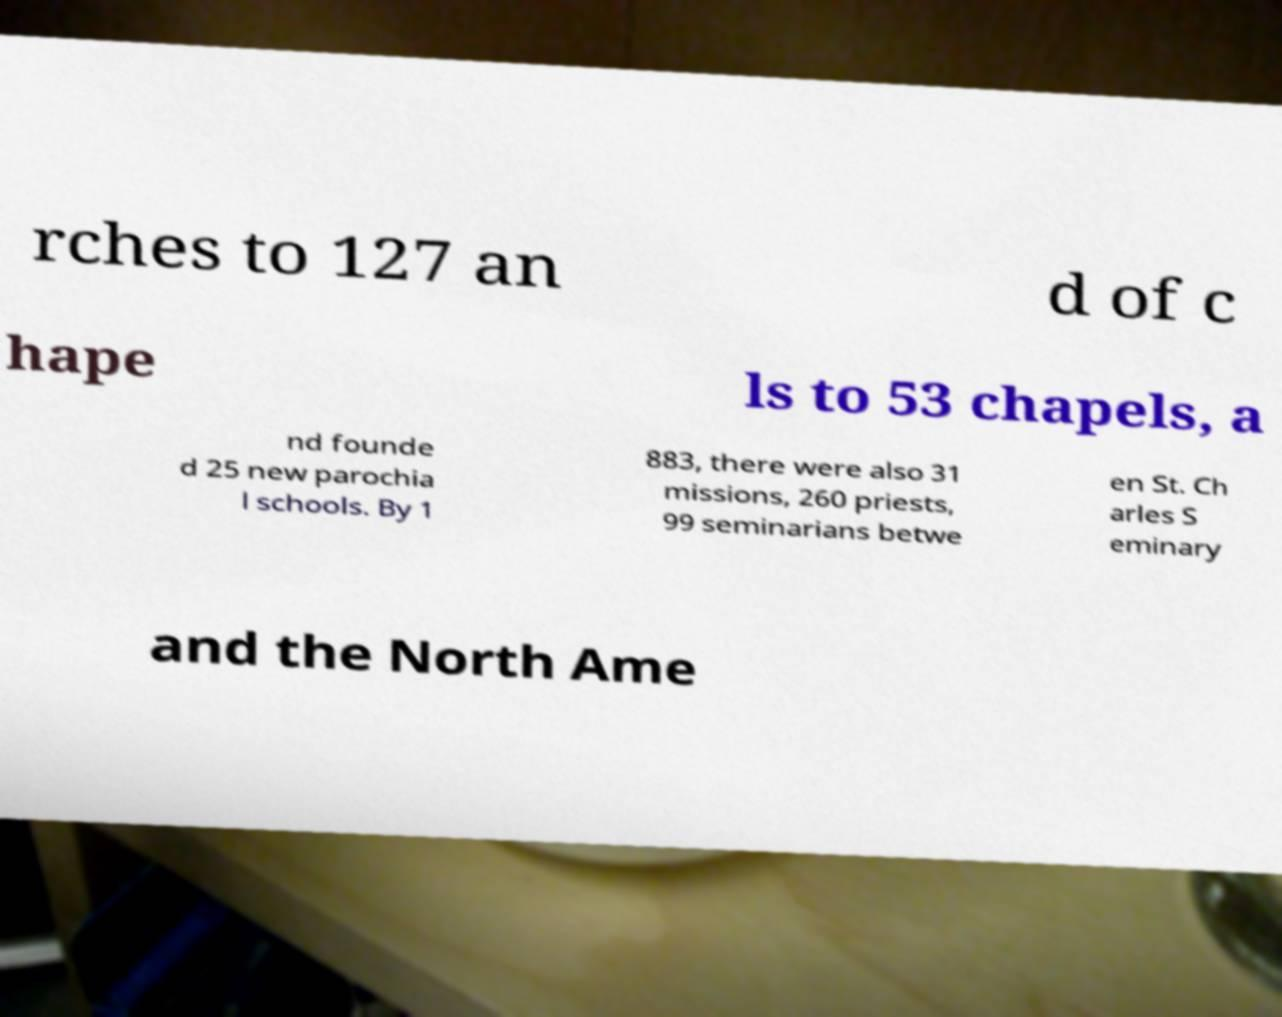Can you accurately transcribe the text from the provided image for me? rches to 127 an d of c hape ls to 53 chapels, a nd founde d 25 new parochia l schools. By 1 883, there were also 31 missions, 260 priests, 99 seminarians betwe en St. Ch arles S eminary and the North Ame 